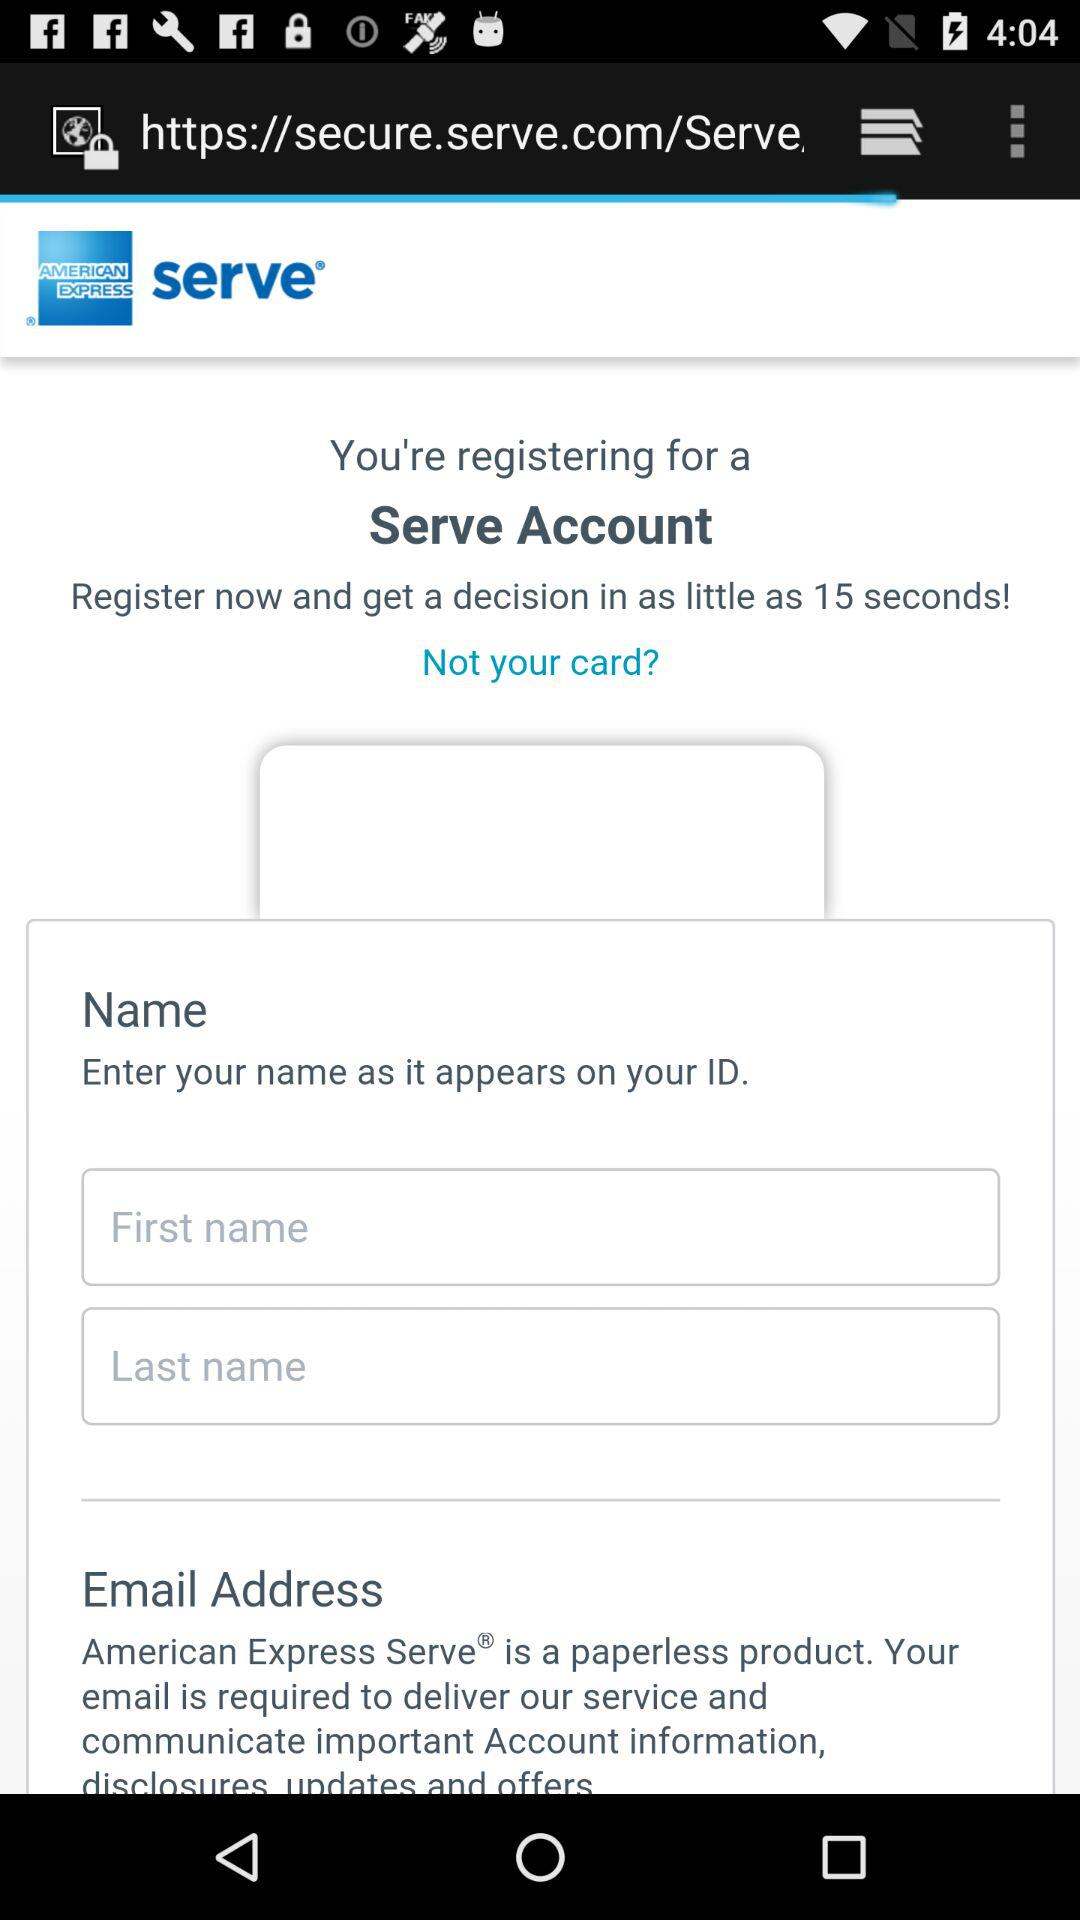In how many seconds do we get a decision after registering? We get a decision in as little as 15 seconds. 